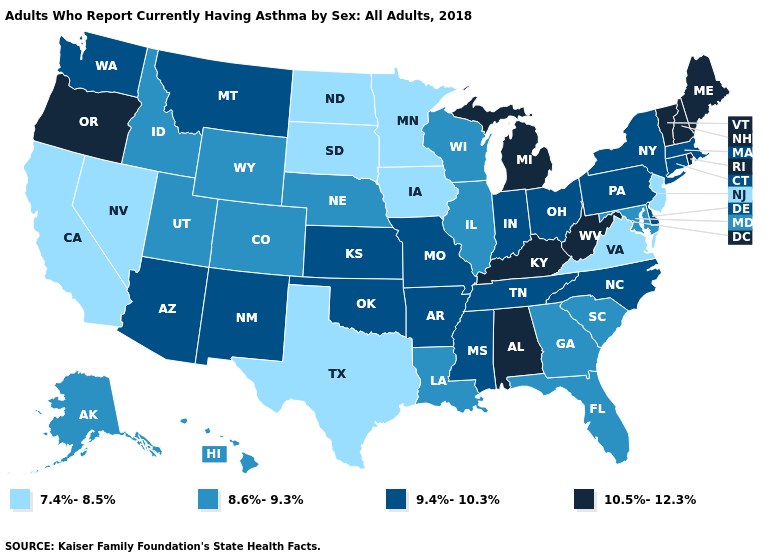Is the legend a continuous bar?
Write a very short answer. No. Which states hav the highest value in the West?
Be succinct. Oregon. Does the map have missing data?
Give a very brief answer. No. What is the lowest value in the Northeast?
Give a very brief answer. 7.4%-8.5%. Name the states that have a value in the range 10.5%-12.3%?
Quick response, please. Alabama, Kentucky, Maine, Michigan, New Hampshire, Oregon, Rhode Island, Vermont, West Virginia. Among the states that border Oregon , which have the lowest value?
Be succinct. California, Nevada. What is the highest value in the USA?
Quick response, please. 10.5%-12.3%. How many symbols are there in the legend?
Answer briefly. 4. What is the highest value in the USA?
Answer briefly. 10.5%-12.3%. Is the legend a continuous bar?
Short answer required. No. Does the map have missing data?
Be succinct. No. What is the value of North Dakota?
Short answer required. 7.4%-8.5%. Which states have the highest value in the USA?
Give a very brief answer. Alabama, Kentucky, Maine, Michigan, New Hampshire, Oregon, Rhode Island, Vermont, West Virginia. Does Idaho have a lower value than South Carolina?
Be succinct. No. Name the states that have a value in the range 9.4%-10.3%?
Give a very brief answer. Arizona, Arkansas, Connecticut, Delaware, Indiana, Kansas, Massachusetts, Mississippi, Missouri, Montana, New Mexico, New York, North Carolina, Ohio, Oklahoma, Pennsylvania, Tennessee, Washington. 